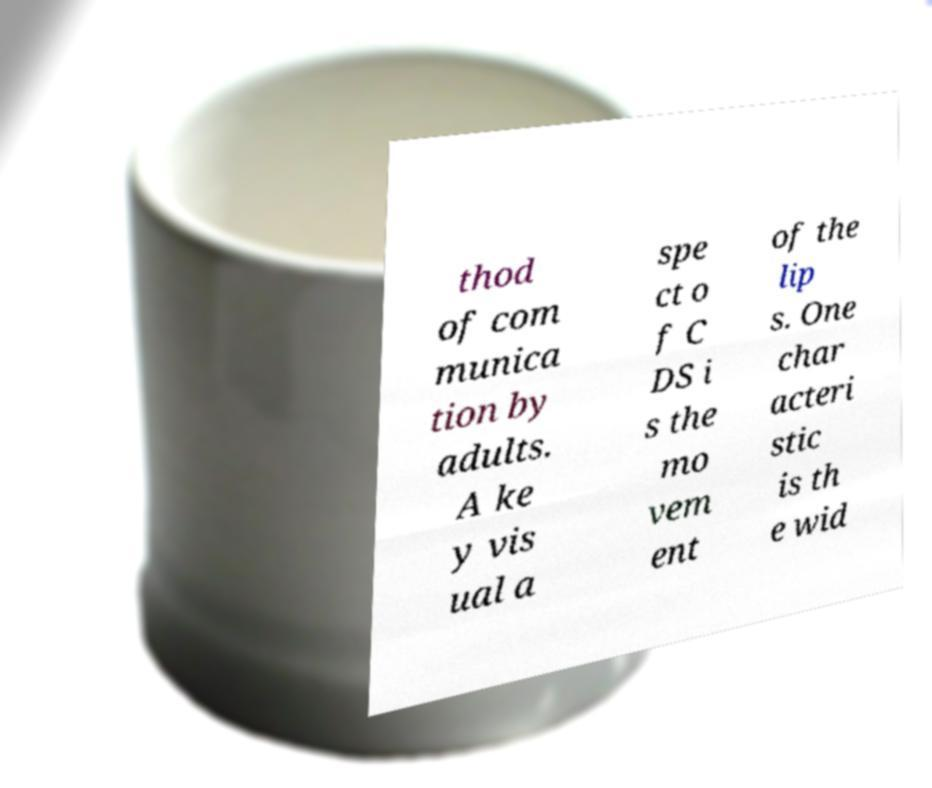I need the written content from this picture converted into text. Can you do that? thod of com munica tion by adults. A ke y vis ual a spe ct o f C DS i s the mo vem ent of the lip s. One char acteri stic is th e wid 